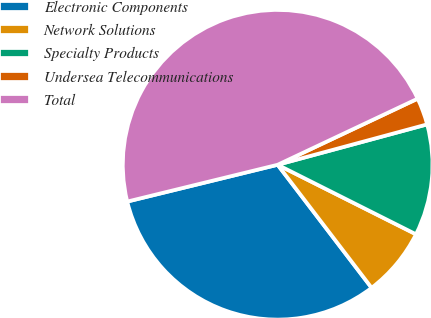Convert chart. <chart><loc_0><loc_0><loc_500><loc_500><pie_chart><fcel>Electronic Components<fcel>Network Solutions<fcel>Specialty Products<fcel>Undersea Telecommunications<fcel>Total<nl><fcel>31.56%<fcel>7.21%<fcel>11.61%<fcel>2.82%<fcel>46.8%<nl></chart> 